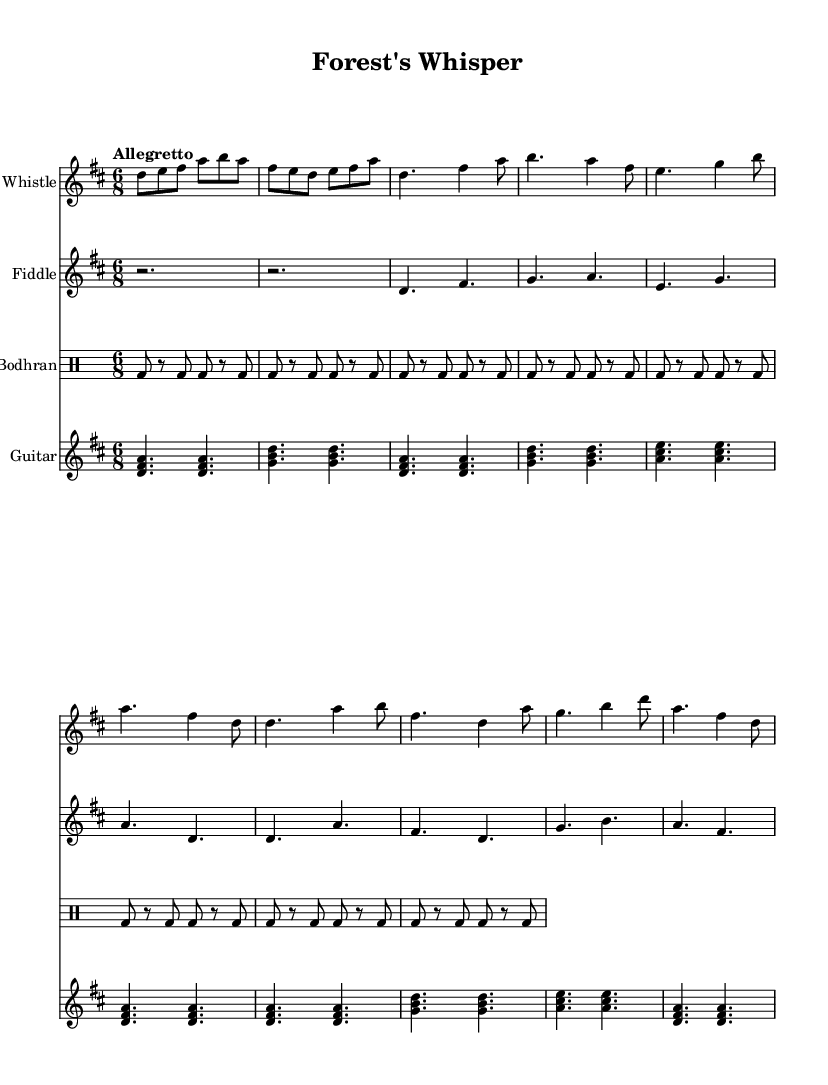What is the key signature of this music? The key signature is D major, which has two sharps (F# and C#). This can be identified in the key signature section at the beginning of the sheet music.
Answer: D major What is the time signature of this music? The time signature is 6/8, indicated at the beginning of the sheet music. It can be recognized by the two numbers, where the upper number represents the number of beats in a measure and the lower number indicates the note value that receives one beat.
Answer: 6/8 What is the tempo marking designated for this piece? The tempo marking is "Allegretto," which describes the speed of the music. This term is visible in the first measures of the sheet music.
Answer: Allegretto How many beats are there in each measure? Each measure contains six beats, as the time signature is 6/8, indicating that there are six eighth notes in a measure. This can be deduced from the time signature itself.
Answer: Six What is the main theme of the lyrics in the song? The main theme of the lyrics celebrates nature and conservation, focusing on preserving the environment for future generations. This theme is evident from the phrases used in both the verse and chorus sections of the song.
Answer: Nature and conservation Which instruments are featured in this music? The instruments featured are Tin Whistle, Fiddle, Bodhran, and Guitar. These can be identified by the labels at the start of each staff on the sheet music.
Answer: Tin Whistle, Fiddle, Bodhran, Guitar What specific cultural element is reflected in the music? The specific cultural element reflected in the music is Celtic folk traditions, which can be inferred from the style of the melodies, rhythms, and overall thematic focus on nature. This aligns with the categorization of the piece as Celtic folk music.
Answer: Celtic folk traditions 